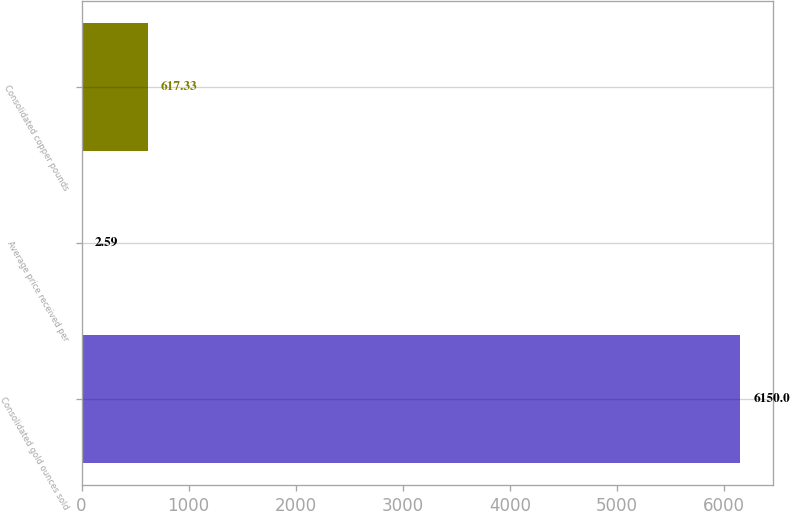<chart> <loc_0><loc_0><loc_500><loc_500><bar_chart><fcel>Consolidated gold ounces sold<fcel>Average price received per<fcel>Consolidated copper pounds<nl><fcel>6150<fcel>2.59<fcel>617.33<nl></chart> 